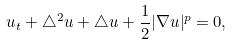<formula> <loc_0><loc_0><loc_500><loc_500>u _ { t } + \triangle ^ { 2 } u + \triangle u + \frac { 1 } { 2 } | \nabla u | ^ { p } = 0 ,</formula> 